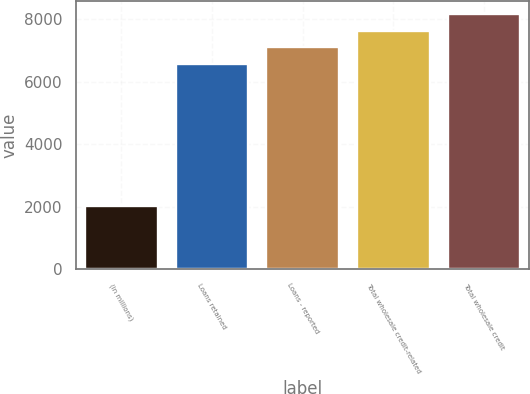Convert chart to OTSL. <chart><loc_0><loc_0><loc_500><loc_500><bar_chart><fcel>(in millions)<fcel>Loans retained<fcel>Loans - reported<fcel>Total wholesale credit-related<fcel>Total wholesale credit<nl><fcel>2009<fcel>6559<fcel>7101.4<fcel>7643.8<fcel>8186.2<nl></chart> 